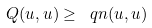Convert formula to latex. <formula><loc_0><loc_0><loc_500><loc_500>Q ( u , u ) \geq \ q n ( u , u )</formula> 